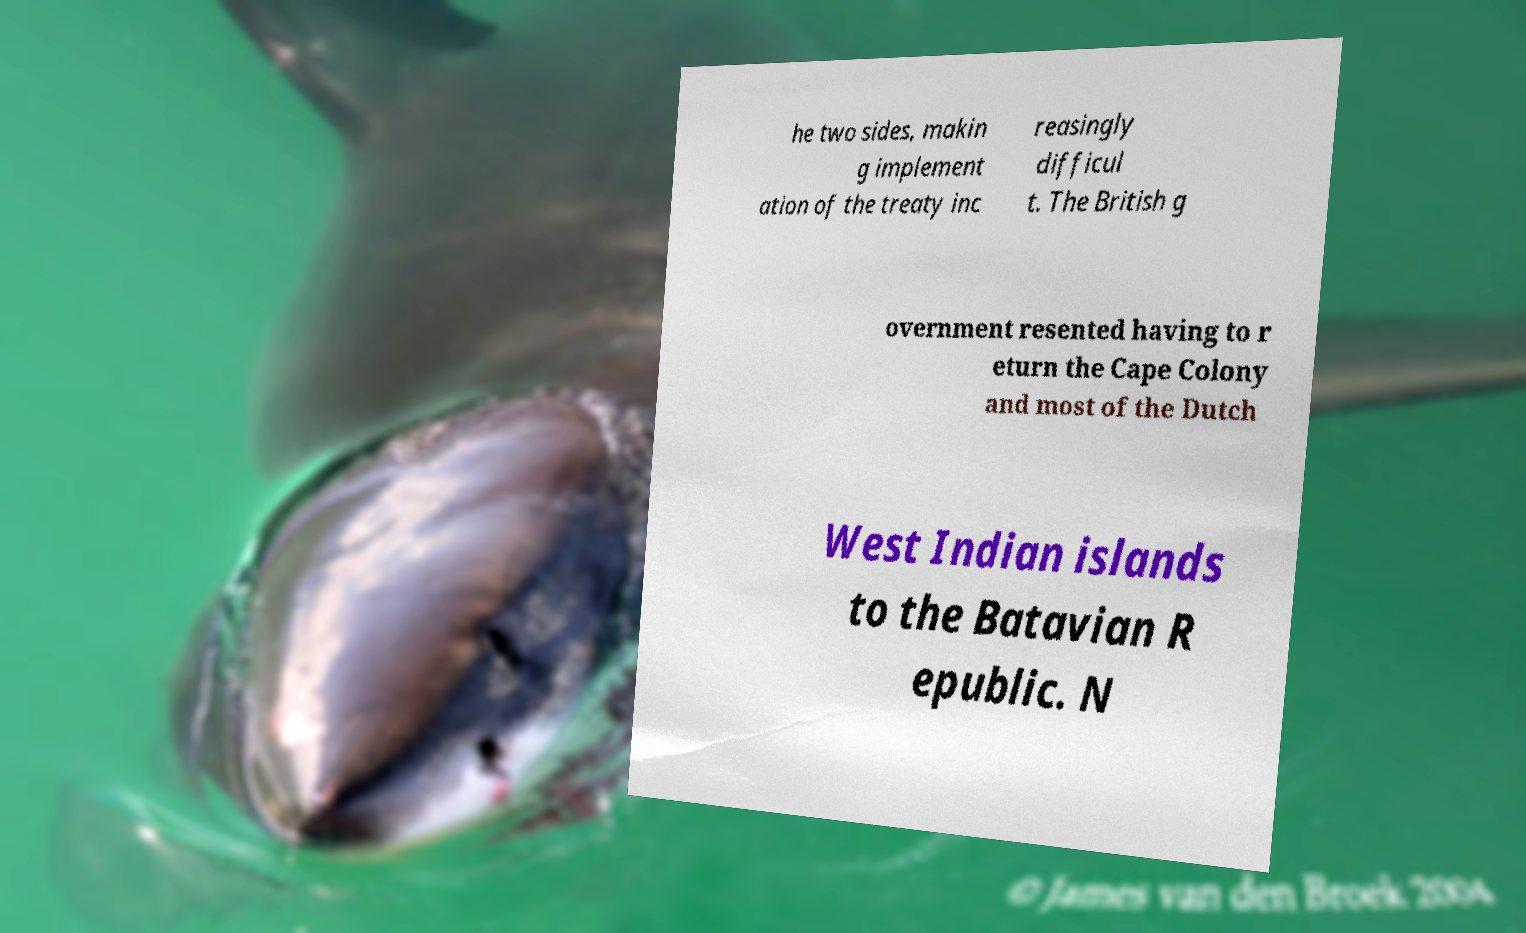What messages or text are displayed in this image? I need them in a readable, typed format. he two sides, makin g implement ation of the treaty inc reasingly difficul t. The British g overnment resented having to r eturn the Cape Colony and most of the Dutch West Indian islands to the Batavian R epublic. N 